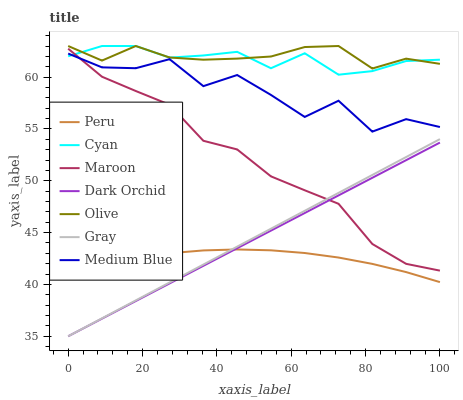Does Medium Blue have the minimum area under the curve?
Answer yes or no. No. Does Medium Blue have the maximum area under the curve?
Answer yes or no. No. Is Medium Blue the smoothest?
Answer yes or no. No. Is Dark Orchid the roughest?
Answer yes or no. No. Does Medium Blue have the lowest value?
Answer yes or no. No. Does Medium Blue have the highest value?
Answer yes or no. No. Is Peru less than Cyan?
Answer yes or no. Yes. Is Olive greater than Medium Blue?
Answer yes or no. Yes. Does Peru intersect Cyan?
Answer yes or no. No. 